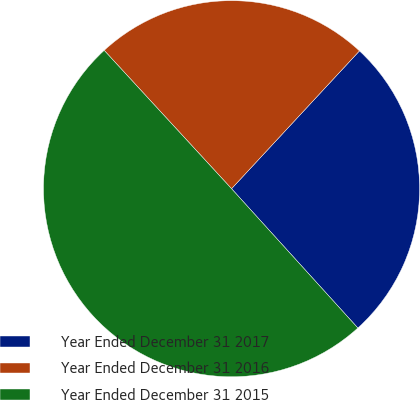<chart> <loc_0><loc_0><loc_500><loc_500><pie_chart><fcel>Year Ended December 31 2017<fcel>Year Ended December 31 2016<fcel>Year Ended December 31 2015<nl><fcel>26.37%<fcel>23.75%<fcel>49.88%<nl></chart> 